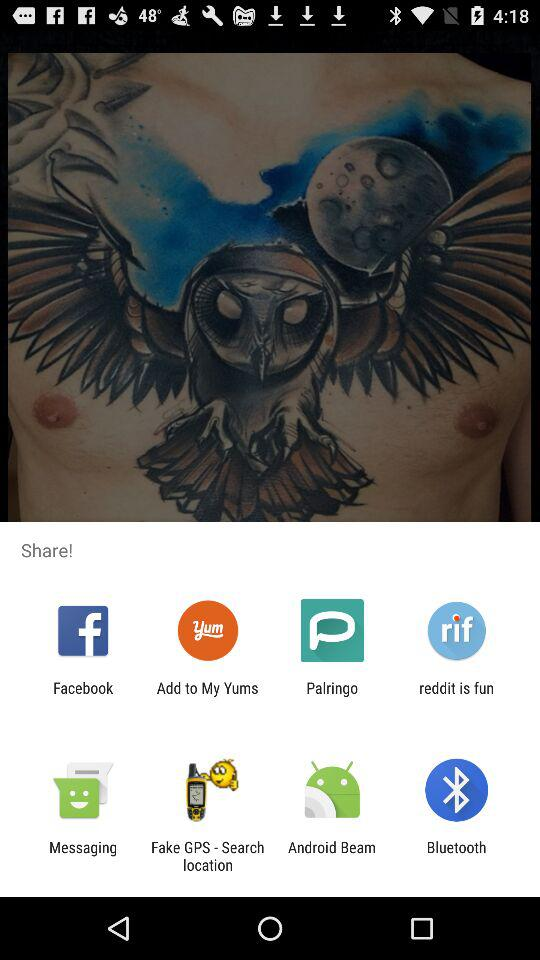Which application can be used to share? The applications that can be used to share are "Facebook", "Add to My Yums", "Palringo", "reddit is fun", "Messaging", "Fake GPS - Search location", "Android Beam" and "Bluetooth". 